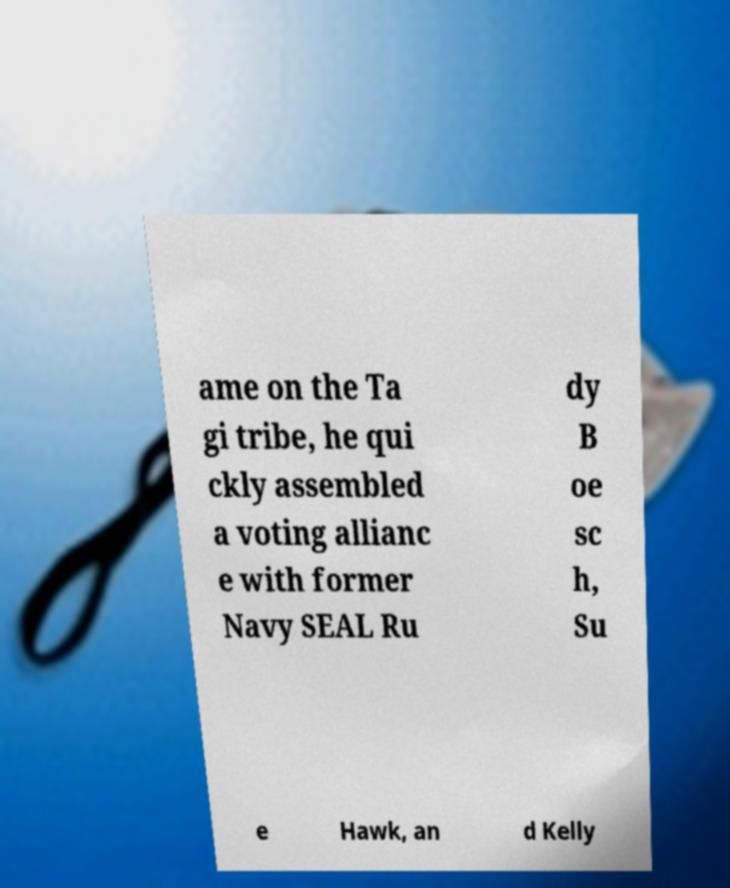Can you accurately transcribe the text from the provided image for me? ame on the Ta gi tribe, he qui ckly assembled a voting allianc e with former Navy SEAL Ru dy B oe sc h, Su e Hawk, an d Kelly 